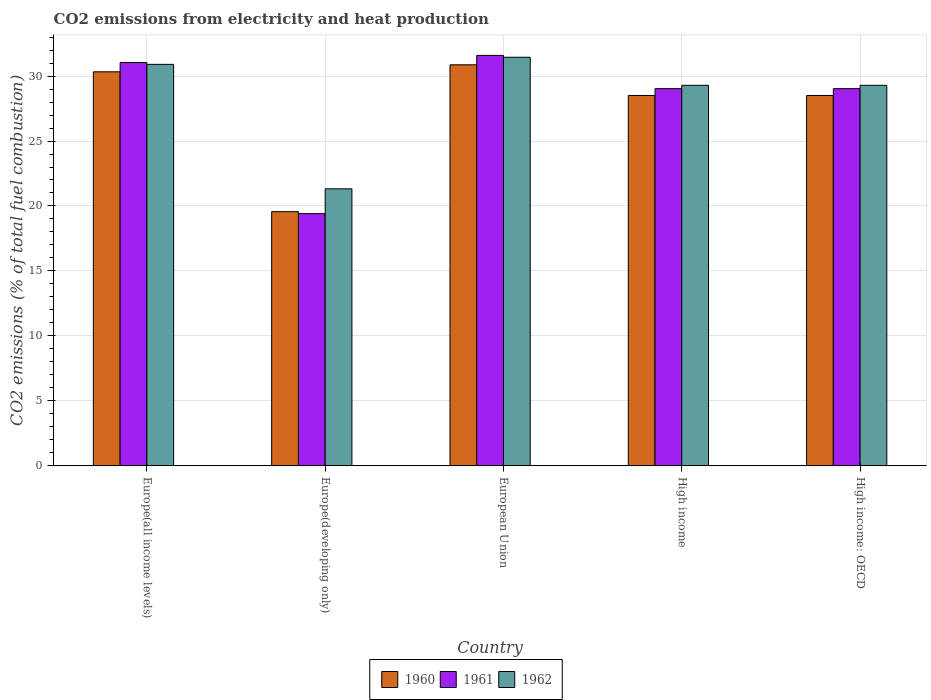How many different coloured bars are there?
Offer a terse response. 3. Are the number of bars on each tick of the X-axis equal?
Ensure brevity in your answer.  Yes. How many bars are there on the 3rd tick from the left?
Keep it short and to the point. 3. What is the label of the 3rd group of bars from the left?
Ensure brevity in your answer.  European Union. In how many cases, is the number of bars for a given country not equal to the number of legend labels?
Give a very brief answer. 0. What is the amount of CO2 emitted in 1960 in High income: OECD?
Make the answer very short. 28.51. Across all countries, what is the maximum amount of CO2 emitted in 1961?
Offer a terse response. 31.59. Across all countries, what is the minimum amount of CO2 emitted in 1962?
Provide a succinct answer. 21.32. In which country was the amount of CO2 emitted in 1961 maximum?
Ensure brevity in your answer.  European Union. In which country was the amount of CO2 emitted in 1960 minimum?
Give a very brief answer. Europe(developing only). What is the total amount of CO2 emitted in 1961 in the graph?
Ensure brevity in your answer.  140.11. What is the difference between the amount of CO2 emitted in 1960 in European Union and that in High income: OECD?
Make the answer very short. 2.36. What is the difference between the amount of CO2 emitted in 1960 in Europe(developing only) and the amount of CO2 emitted in 1961 in High income?
Offer a terse response. -9.47. What is the average amount of CO2 emitted in 1962 per country?
Your response must be concise. 28.45. What is the difference between the amount of CO2 emitted of/in 1962 and amount of CO2 emitted of/in 1961 in Europe(all income levels)?
Make the answer very short. -0.14. In how many countries, is the amount of CO2 emitted in 1962 greater than 28 %?
Give a very brief answer. 4. What is the ratio of the amount of CO2 emitted in 1961 in Europe(developing only) to that in High income?
Your answer should be very brief. 0.67. Is the amount of CO2 emitted in 1961 in Europe(developing only) less than that in European Union?
Make the answer very short. Yes. What is the difference between the highest and the second highest amount of CO2 emitted in 1962?
Offer a terse response. -1.61. What is the difference between the highest and the lowest amount of CO2 emitted in 1960?
Your answer should be compact. 11.31. In how many countries, is the amount of CO2 emitted in 1961 greater than the average amount of CO2 emitted in 1961 taken over all countries?
Your response must be concise. 4. Is the sum of the amount of CO2 emitted in 1961 in High income and High income: OECD greater than the maximum amount of CO2 emitted in 1962 across all countries?
Offer a terse response. Yes. Is it the case that in every country, the sum of the amount of CO2 emitted in 1961 and amount of CO2 emitted in 1962 is greater than the amount of CO2 emitted in 1960?
Provide a short and direct response. Yes. How many bars are there?
Give a very brief answer. 15. How many countries are there in the graph?
Provide a succinct answer. 5. What is the difference between two consecutive major ticks on the Y-axis?
Give a very brief answer. 5. Are the values on the major ticks of Y-axis written in scientific E-notation?
Offer a very short reply. No. Does the graph contain any zero values?
Provide a short and direct response. No. How many legend labels are there?
Offer a very short reply. 3. What is the title of the graph?
Your response must be concise. CO2 emissions from electricity and heat production. Does "1973" appear as one of the legend labels in the graph?
Keep it short and to the point. No. What is the label or title of the Y-axis?
Offer a terse response. CO2 emissions (% of total fuel combustion). What is the CO2 emissions (% of total fuel combustion) in 1960 in Europe(all income levels)?
Ensure brevity in your answer.  30.33. What is the CO2 emissions (% of total fuel combustion) of 1961 in Europe(all income levels)?
Keep it short and to the point. 31.04. What is the CO2 emissions (% of total fuel combustion) in 1962 in Europe(all income levels)?
Provide a succinct answer. 30.9. What is the CO2 emissions (% of total fuel combustion) in 1960 in Europe(developing only)?
Provide a succinct answer. 19.56. What is the CO2 emissions (% of total fuel combustion) in 1961 in Europe(developing only)?
Give a very brief answer. 19.41. What is the CO2 emissions (% of total fuel combustion) in 1962 in Europe(developing only)?
Your answer should be compact. 21.32. What is the CO2 emissions (% of total fuel combustion) of 1960 in European Union?
Give a very brief answer. 30.87. What is the CO2 emissions (% of total fuel combustion) of 1961 in European Union?
Your answer should be very brief. 31.59. What is the CO2 emissions (% of total fuel combustion) of 1962 in European Union?
Give a very brief answer. 31.45. What is the CO2 emissions (% of total fuel combustion) in 1960 in High income?
Provide a succinct answer. 28.51. What is the CO2 emissions (% of total fuel combustion) in 1961 in High income?
Your answer should be compact. 29.03. What is the CO2 emissions (% of total fuel combustion) of 1962 in High income?
Offer a very short reply. 29.29. What is the CO2 emissions (% of total fuel combustion) of 1960 in High income: OECD?
Ensure brevity in your answer.  28.51. What is the CO2 emissions (% of total fuel combustion) in 1961 in High income: OECD?
Provide a short and direct response. 29.03. What is the CO2 emissions (% of total fuel combustion) of 1962 in High income: OECD?
Offer a terse response. 29.29. Across all countries, what is the maximum CO2 emissions (% of total fuel combustion) in 1960?
Provide a succinct answer. 30.87. Across all countries, what is the maximum CO2 emissions (% of total fuel combustion) of 1961?
Offer a terse response. 31.59. Across all countries, what is the maximum CO2 emissions (% of total fuel combustion) in 1962?
Give a very brief answer. 31.45. Across all countries, what is the minimum CO2 emissions (% of total fuel combustion) of 1960?
Keep it short and to the point. 19.56. Across all countries, what is the minimum CO2 emissions (% of total fuel combustion) of 1961?
Your answer should be compact. 19.41. Across all countries, what is the minimum CO2 emissions (% of total fuel combustion) in 1962?
Ensure brevity in your answer.  21.32. What is the total CO2 emissions (% of total fuel combustion) of 1960 in the graph?
Your answer should be compact. 137.77. What is the total CO2 emissions (% of total fuel combustion) of 1961 in the graph?
Your response must be concise. 140.11. What is the total CO2 emissions (% of total fuel combustion) in 1962 in the graph?
Your response must be concise. 142.25. What is the difference between the CO2 emissions (% of total fuel combustion) in 1960 in Europe(all income levels) and that in Europe(developing only)?
Keep it short and to the point. 10.77. What is the difference between the CO2 emissions (% of total fuel combustion) of 1961 in Europe(all income levels) and that in Europe(developing only)?
Offer a very short reply. 11.64. What is the difference between the CO2 emissions (% of total fuel combustion) of 1962 in Europe(all income levels) and that in Europe(developing only)?
Offer a very short reply. 9.58. What is the difference between the CO2 emissions (% of total fuel combustion) of 1960 in Europe(all income levels) and that in European Union?
Offer a very short reply. -0.54. What is the difference between the CO2 emissions (% of total fuel combustion) in 1961 in Europe(all income levels) and that in European Union?
Your answer should be compact. -0.55. What is the difference between the CO2 emissions (% of total fuel combustion) in 1962 in Europe(all income levels) and that in European Union?
Give a very brief answer. -0.55. What is the difference between the CO2 emissions (% of total fuel combustion) of 1960 in Europe(all income levels) and that in High income?
Give a very brief answer. 1.82. What is the difference between the CO2 emissions (% of total fuel combustion) of 1961 in Europe(all income levels) and that in High income?
Give a very brief answer. 2.01. What is the difference between the CO2 emissions (% of total fuel combustion) in 1962 in Europe(all income levels) and that in High income?
Provide a succinct answer. 1.61. What is the difference between the CO2 emissions (% of total fuel combustion) in 1960 in Europe(all income levels) and that in High income: OECD?
Your answer should be very brief. 1.82. What is the difference between the CO2 emissions (% of total fuel combustion) in 1961 in Europe(all income levels) and that in High income: OECD?
Make the answer very short. 2.01. What is the difference between the CO2 emissions (% of total fuel combustion) in 1962 in Europe(all income levels) and that in High income: OECD?
Your answer should be very brief. 1.61. What is the difference between the CO2 emissions (% of total fuel combustion) of 1960 in Europe(developing only) and that in European Union?
Give a very brief answer. -11.31. What is the difference between the CO2 emissions (% of total fuel combustion) in 1961 in Europe(developing only) and that in European Union?
Your answer should be very brief. -12.19. What is the difference between the CO2 emissions (% of total fuel combustion) in 1962 in Europe(developing only) and that in European Union?
Offer a terse response. -10.13. What is the difference between the CO2 emissions (% of total fuel combustion) of 1960 in Europe(developing only) and that in High income?
Ensure brevity in your answer.  -8.94. What is the difference between the CO2 emissions (% of total fuel combustion) in 1961 in Europe(developing only) and that in High income?
Ensure brevity in your answer.  -9.62. What is the difference between the CO2 emissions (% of total fuel combustion) of 1962 in Europe(developing only) and that in High income?
Your answer should be compact. -7.97. What is the difference between the CO2 emissions (% of total fuel combustion) of 1960 in Europe(developing only) and that in High income: OECD?
Give a very brief answer. -8.94. What is the difference between the CO2 emissions (% of total fuel combustion) in 1961 in Europe(developing only) and that in High income: OECD?
Give a very brief answer. -9.62. What is the difference between the CO2 emissions (% of total fuel combustion) in 1962 in Europe(developing only) and that in High income: OECD?
Provide a succinct answer. -7.97. What is the difference between the CO2 emissions (% of total fuel combustion) in 1960 in European Union and that in High income?
Your answer should be very brief. 2.36. What is the difference between the CO2 emissions (% of total fuel combustion) in 1961 in European Union and that in High income?
Your response must be concise. 2.56. What is the difference between the CO2 emissions (% of total fuel combustion) in 1962 in European Union and that in High income?
Your answer should be compact. 2.16. What is the difference between the CO2 emissions (% of total fuel combustion) of 1960 in European Union and that in High income: OECD?
Your response must be concise. 2.36. What is the difference between the CO2 emissions (% of total fuel combustion) in 1961 in European Union and that in High income: OECD?
Offer a very short reply. 2.56. What is the difference between the CO2 emissions (% of total fuel combustion) in 1962 in European Union and that in High income: OECD?
Give a very brief answer. 2.16. What is the difference between the CO2 emissions (% of total fuel combustion) in 1960 in High income and that in High income: OECD?
Offer a terse response. 0. What is the difference between the CO2 emissions (% of total fuel combustion) of 1961 in High income and that in High income: OECD?
Your answer should be compact. 0. What is the difference between the CO2 emissions (% of total fuel combustion) in 1962 in High income and that in High income: OECD?
Keep it short and to the point. 0. What is the difference between the CO2 emissions (% of total fuel combustion) of 1960 in Europe(all income levels) and the CO2 emissions (% of total fuel combustion) of 1961 in Europe(developing only)?
Give a very brief answer. 10.92. What is the difference between the CO2 emissions (% of total fuel combustion) in 1960 in Europe(all income levels) and the CO2 emissions (% of total fuel combustion) in 1962 in Europe(developing only)?
Your answer should be very brief. 9.01. What is the difference between the CO2 emissions (% of total fuel combustion) in 1961 in Europe(all income levels) and the CO2 emissions (% of total fuel combustion) in 1962 in Europe(developing only)?
Ensure brevity in your answer.  9.73. What is the difference between the CO2 emissions (% of total fuel combustion) in 1960 in Europe(all income levels) and the CO2 emissions (% of total fuel combustion) in 1961 in European Union?
Your response must be concise. -1.26. What is the difference between the CO2 emissions (% of total fuel combustion) in 1960 in Europe(all income levels) and the CO2 emissions (% of total fuel combustion) in 1962 in European Union?
Your response must be concise. -1.12. What is the difference between the CO2 emissions (% of total fuel combustion) of 1961 in Europe(all income levels) and the CO2 emissions (% of total fuel combustion) of 1962 in European Union?
Provide a short and direct response. -0.41. What is the difference between the CO2 emissions (% of total fuel combustion) in 1960 in Europe(all income levels) and the CO2 emissions (% of total fuel combustion) in 1961 in High income?
Ensure brevity in your answer.  1.3. What is the difference between the CO2 emissions (% of total fuel combustion) in 1960 in Europe(all income levels) and the CO2 emissions (% of total fuel combustion) in 1962 in High income?
Offer a terse response. 1.04. What is the difference between the CO2 emissions (% of total fuel combustion) of 1961 in Europe(all income levels) and the CO2 emissions (% of total fuel combustion) of 1962 in High income?
Offer a very short reply. 1.75. What is the difference between the CO2 emissions (% of total fuel combustion) in 1960 in Europe(all income levels) and the CO2 emissions (% of total fuel combustion) in 1961 in High income: OECD?
Make the answer very short. 1.3. What is the difference between the CO2 emissions (% of total fuel combustion) of 1960 in Europe(all income levels) and the CO2 emissions (% of total fuel combustion) of 1962 in High income: OECD?
Offer a very short reply. 1.04. What is the difference between the CO2 emissions (% of total fuel combustion) in 1961 in Europe(all income levels) and the CO2 emissions (% of total fuel combustion) in 1962 in High income: OECD?
Give a very brief answer. 1.75. What is the difference between the CO2 emissions (% of total fuel combustion) of 1960 in Europe(developing only) and the CO2 emissions (% of total fuel combustion) of 1961 in European Union?
Your answer should be very brief. -12.03. What is the difference between the CO2 emissions (% of total fuel combustion) in 1960 in Europe(developing only) and the CO2 emissions (% of total fuel combustion) in 1962 in European Union?
Ensure brevity in your answer.  -11.89. What is the difference between the CO2 emissions (% of total fuel combustion) of 1961 in Europe(developing only) and the CO2 emissions (% of total fuel combustion) of 1962 in European Union?
Your answer should be very brief. -12.04. What is the difference between the CO2 emissions (% of total fuel combustion) of 1960 in Europe(developing only) and the CO2 emissions (% of total fuel combustion) of 1961 in High income?
Keep it short and to the point. -9.47. What is the difference between the CO2 emissions (% of total fuel combustion) in 1960 in Europe(developing only) and the CO2 emissions (% of total fuel combustion) in 1962 in High income?
Give a very brief answer. -9.73. What is the difference between the CO2 emissions (% of total fuel combustion) in 1961 in Europe(developing only) and the CO2 emissions (% of total fuel combustion) in 1962 in High income?
Your answer should be compact. -9.88. What is the difference between the CO2 emissions (% of total fuel combustion) in 1960 in Europe(developing only) and the CO2 emissions (% of total fuel combustion) in 1961 in High income: OECD?
Make the answer very short. -9.47. What is the difference between the CO2 emissions (% of total fuel combustion) in 1960 in Europe(developing only) and the CO2 emissions (% of total fuel combustion) in 1962 in High income: OECD?
Provide a short and direct response. -9.73. What is the difference between the CO2 emissions (% of total fuel combustion) in 1961 in Europe(developing only) and the CO2 emissions (% of total fuel combustion) in 1962 in High income: OECD?
Offer a very short reply. -9.88. What is the difference between the CO2 emissions (% of total fuel combustion) of 1960 in European Union and the CO2 emissions (% of total fuel combustion) of 1961 in High income?
Your answer should be very brief. 1.84. What is the difference between the CO2 emissions (% of total fuel combustion) of 1960 in European Union and the CO2 emissions (% of total fuel combustion) of 1962 in High income?
Ensure brevity in your answer.  1.58. What is the difference between the CO2 emissions (% of total fuel combustion) of 1961 in European Union and the CO2 emissions (% of total fuel combustion) of 1962 in High income?
Ensure brevity in your answer.  2.3. What is the difference between the CO2 emissions (% of total fuel combustion) of 1960 in European Union and the CO2 emissions (% of total fuel combustion) of 1961 in High income: OECD?
Offer a very short reply. 1.84. What is the difference between the CO2 emissions (% of total fuel combustion) of 1960 in European Union and the CO2 emissions (% of total fuel combustion) of 1962 in High income: OECD?
Give a very brief answer. 1.58. What is the difference between the CO2 emissions (% of total fuel combustion) of 1961 in European Union and the CO2 emissions (% of total fuel combustion) of 1962 in High income: OECD?
Give a very brief answer. 2.3. What is the difference between the CO2 emissions (% of total fuel combustion) of 1960 in High income and the CO2 emissions (% of total fuel combustion) of 1961 in High income: OECD?
Offer a terse response. -0.53. What is the difference between the CO2 emissions (% of total fuel combustion) in 1960 in High income and the CO2 emissions (% of total fuel combustion) in 1962 in High income: OECD?
Provide a short and direct response. -0.78. What is the difference between the CO2 emissions (% of total fuel combustion) of 1961 in High income and the CO2 emissions (% of total fuel combustion) of 1962 in High income: OECD?
Your answer should be compact. -0.26. What is the average CO2 emissions (% of total fuel combustion) of 1960 per country?
Keep it short and to the point. 27.55. What is the average CO2 emissions (% of total fuel combustion) in 1961 per country?
Ensure brevity in your answer.  28.02. What is the average CO2 emissions (% of total fuel combustion) in 1962 per country?
Ensure brevity in your answer.  28.45. What is the difference between the CO2 emissions (% of total fuel combustion) in 1960 and CO2 emissions (% of total fuel combustion) in 1961 in Europe(all income levels)?
Make the answer very short. -0.71. What is the difference between the CO2 emissions (% of total fuel combustion) of 1960 and CO2 emissions (% of total fuel combustion) of 1962 in Europe(all income levels)?
Keep it short and to the point. -0.57. What is the difference between the CO2 emissions (% of total fuel combustion) of 1961 and CO2 emissions (% of total fuel combustion) of 1962 in Europe(all income levels)?
Your answer should be very brief. 0.14. What is the difference between the CO2 emissions (% of total fuel combustion) in 1960 and CO2 emissions (% of total fuel combustion) in 1961 in Europe(developing only)?
Give a very brief answer. 0.15. What is the difference between the CO2 emissions (% of total fuel combustion) in 1960 and CO2 emissions (% of total fuel combustion) in 1962 in Europe(developing only)?
Your response must be concise. -1.76. What is the difference between the CO2 emissions (% of total fuel combustion) in 1961 and CO2 emissions (% of total fuel combustion) in 1962 in Europe(developing only)?
Your response must be concise. -1.91. What is the difference between the CO2 emissions (% of total fuel combustion) of 1960 and CO2 emissions (% of total fuel combustion) of 1961 in European Union?
Provide a short and direct response. -0.73. What is the difference between the CO2 emissions (% of total fuel combustion) in 1960 and CO2 emissions (% of total fuel combustion) in 1962 in European Union?
Your response must be concise. -0.58. What is the difference between the CO2 emissions (% of total fuel combustion) in 1961 and CO2 emissions (% of total fuel combustion) in 1962 in European Union?
Provide a short and direct response. 0.14. What is the difference between the CO2 emissions (% of total fuel combustion) of 1960 and CO2 emissions (% of total fuel combustion) of 1961 in High income?
Provide a succinct answer. -0.53. What is the difference between the CO2 emissions (% of total fuel combustion) of 1960 and CO2 emissions (% of total fuel combustion) of 1962 in High income?
Give a very brief answer. -0.78. What is the difference between the CO2 emissions (% of total fuel combustion) in 1961 and CO2 emissions (% of total fuel combustion) in 1962 in High income?
Offer a terse response. -0.26. What is the difference between the CO2 emissions (% of total fuel combustion) of 1960 and CO2 emissions (% of total fuel combustion) of 1961 in High income: OECD?
Make the answer very short. -0.53. What is the difference between the CO2 emissions (% of total fuel combustion) of 1960 and CO2 emissions (% of total fuel combustion) of 1962 in High income: OECD?
Provide a succinct answer. -0.78. What is the difference between the CO2 emissions (% of total fuel combustion) of 1961 and CO2 emissions (% of total fuel combustion) of 1962 in High income: OECD?
Your response must be concise. -0.26. What is the ratio of the CO2 emissions (% of total fuel combustion) of 1960 in Europe(all income levels) to that in Europe(developing only)?
Offer a very short reply. 1.55. What is the ratio of the CO2 emissions (% of total fuel combustion) of 1961 in Europe(all income levels) to that in Europe(developing only)?
Give a very brief answer. 1.6. What is the ratio of the CO2 emissions (% of total fuel combustion) in 1962 in Europe(all income levels) to that in Europe(developing only)?
Your response must be concise. 1.45. What is the ratio of the CO2 emissions (% of total fuel combustion) of 1960 in Europe(all income levels) to that in European Union?
Your response must be concise. 0.98. What is the ratio of the CO2 emissions (% of total fuel combustion) of 1961 in Europe(all income levels) to that in European Union?
Your answer should be compact. 0.98. What is the ratio of the CO2 emissions (% of total fuel combustion) of 1962 in Europe(all income levels) to that in European Union?
Provide a short and direct response. 0.98. What is the ratio of the CO2 emissions (% of total fuel combustion) of 1960 in Europe(all income levels) to that in High income?
Your answer should be compact. 1.06. What is the ratio of the CO2 emissions (% of total fuel combustion) in 1961 in Europe(all income levels) to that in High income?
Keep it short and to the point. 1.07. What is the ratio of the CO2 emissions (% of total fuel combustion) of 1962 in Europe(all income levels) to that in High income?
Your response must be concise. 1.06. What is the ratio of the CO2 emissions (% of total fuel combustion) of 1960 in Europe(all income levels) to that in High income: OECD?
Your answer should be very brief. 1.06. What is the ratio of the CO2 emissions (% of total fuel combustion) of 1961 in Europe(all income levels) to that in High income: OECD?
Your answer should be very brief. 1.07. What is the ratio of the CO2 emissions (% of total fuel combustion) in 1962 in Europe(all income levels) to that in High income: OECD?
Give a very brief answer. 1.06. What is the ratio of the CO2 emissions (% of total fuel combustion) in 1960 in Europe(developing only) to that in European Union?
Make the answer very short. 0.63. What is the ratio of the CO2 emissions (% of total fuel combustion) of 1961 in Europe(developing only) to that in European Union?
Make the answer very short. 0.61. What is the ratio of the CO2 emissions (% of total fuel combustion) of 1962 in Europe(developing only) to that in European Union?
Offer a terse response. 0.68. What is the ratio of the CO2 emissions (% of total fuel combustion) of 1960 in Europe(developing only) to that in High income?
Offer a very short reply. 0.69. What is the ratio of the CO2 emissions (% of total fuel combustion) in 1961 in Europe(developing only) to that in High income?
Provide a succinct answer. 0.67. What is the ratio of the CO2 emissions (% of total fuel combustion) of 1962 in Europe(developing only) to that in High income?
Offer a terse response. 0.73. What is the ratio of the CO2 emissions (% of total fuel combustion) of 1960 in Europe(developing only) to that in High income: OECD?
Provide a succinct answer. 0.69. What is the ratio of the CO2 emissions (% of total fuel combustion) in 1961 in Europe(developing only) to that in High income: OECD?
Your answer should be very brief. 0.67. What is the ratio of the CO2 emissions (% of total fuel combustion) of 1962 in Europe(developing only) to that in High income: OECD?
Offer a very short reply. 0.73. What is the ratio of the CO2 emissions (% of total fuel combustion) in 1960 in European Union to that in High income?
Your response must be concise. 1.08. What is the ratio of the CO2 emissions (% of total fuel combustion) in 1961 in European Union to that in High income?
Ensure brevity in your answer.  1.09. What is the ratio of the CO2 emissions (% of total fuel combustion) in 1962 in European Union to that in High income?
Give a very brief answer. 1.07. What is the ratio of the CO2 emissions (% of total fuel combustion) of 1960 in European Union to that in High income: OECD?
Your response must be concise. 1.08. What is the ratio of the CO2 emissions (% of total fuel combustion) in 1961 in European Union to that in High income: OECD?
Provide a short and direct response. 1.09. What is the ratio of the CO2 emissions (% of total fuel combustion) of 1962 in European Union to that in High income: OECD?
Your answer should be compact. 1.07. What is the difference between the highest and the second highest CO2 emissions (% of total fuel combustion) in 1960?
Offer a terse response. 0.54. What is the difference between the highest and the second highest CO2 emissions (% of total fuel combustion) of 1961?
Your response must be concise. 0.55. What is the difference between the highest and the second highest CO2 emissions (% of total fuel combustion) in 1962?
Provide a succinct answer. 0.55. What is the difference between the highest and the lowest CO2 emissions (% of total fuel combustion) of 1960?
Keep it short and to the point. 11.31. What is the difference between the highest and the lowest CO2 emissions (% of total fuel combustion) of 1961?
Your answer should be very brief. 12.19. What is the difference between the highest and the lowest CO2 emissions (% of total fuel combustion) of 1962?
Keep it short and to the point. 10.13. 